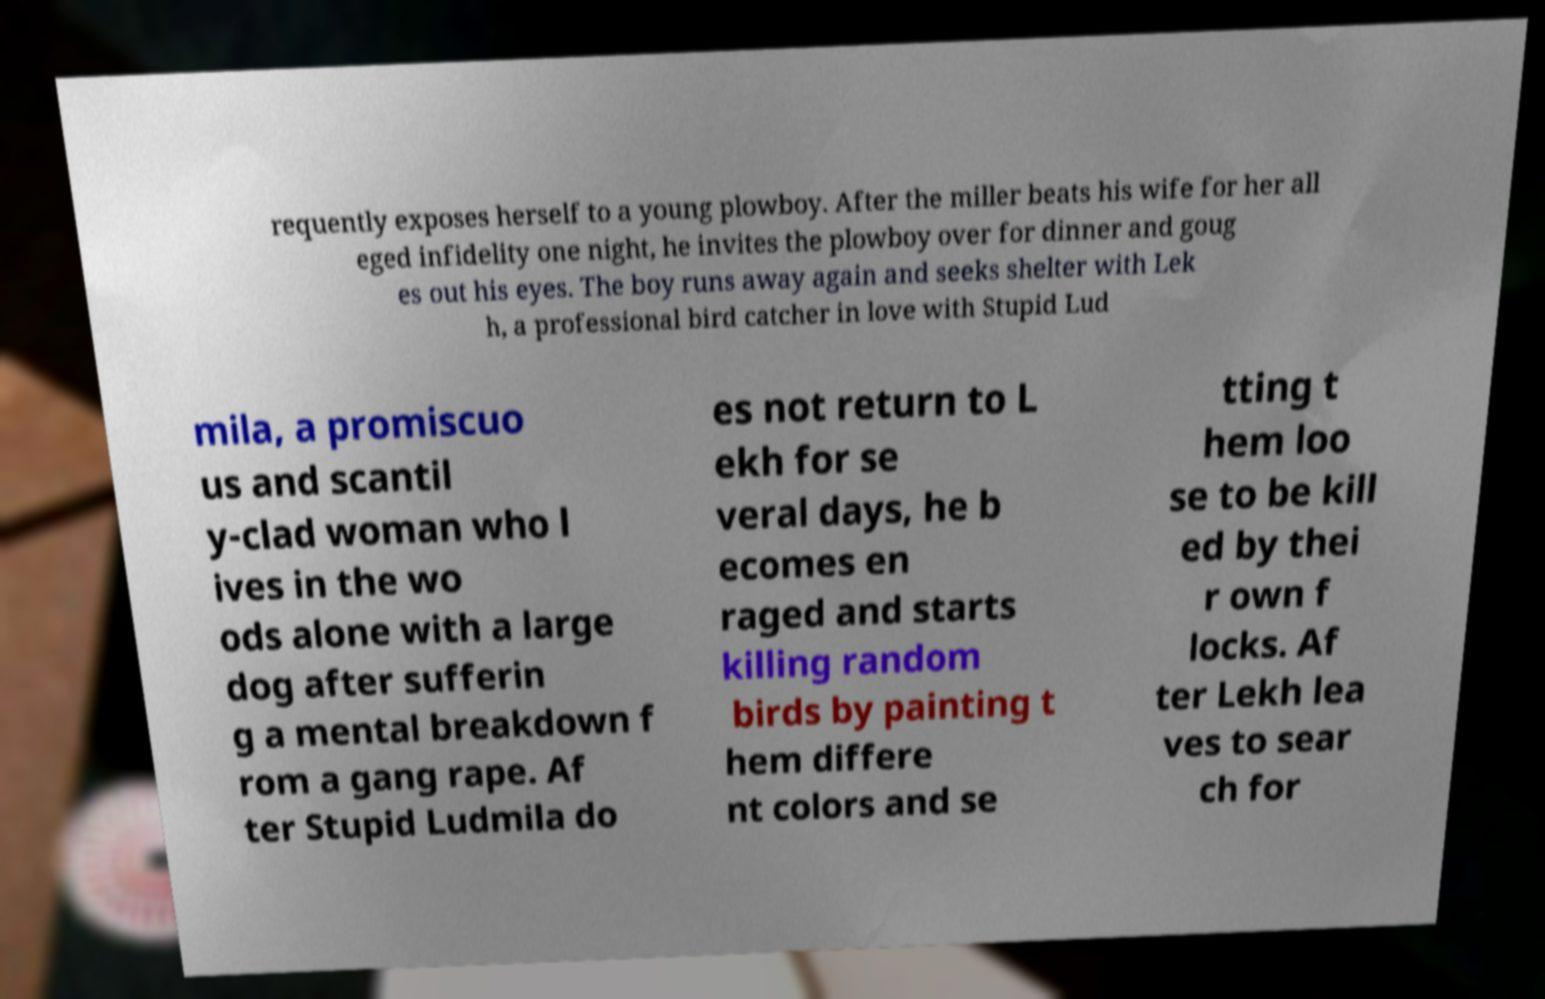Please read and relay the text visible in this image. What does it say? requently exposes herself to a young plowboy. After the miller beats his wife for her all eged infidelity one night, he invites the plowboy over for dinner and goug es out his eyes. The boy runs away again and seeks shelter with Lek h, a professional bird catcher in love with Stupid Lud mila, a promiscuo us and scantil y-clad woman who l ives in the wo ods alone with a large dog after sufferin g a mental breakdown f rom a gang rape. Af ter Stupid Ludmila do es not return to L ekh for se veral days, he b ecomes en raged and starts killing random birds by painting t hem differe nt colors and se tting t hem loo se to be kill ed by thei r own f locks. Af ter Lekh lea ves to sear ch for 